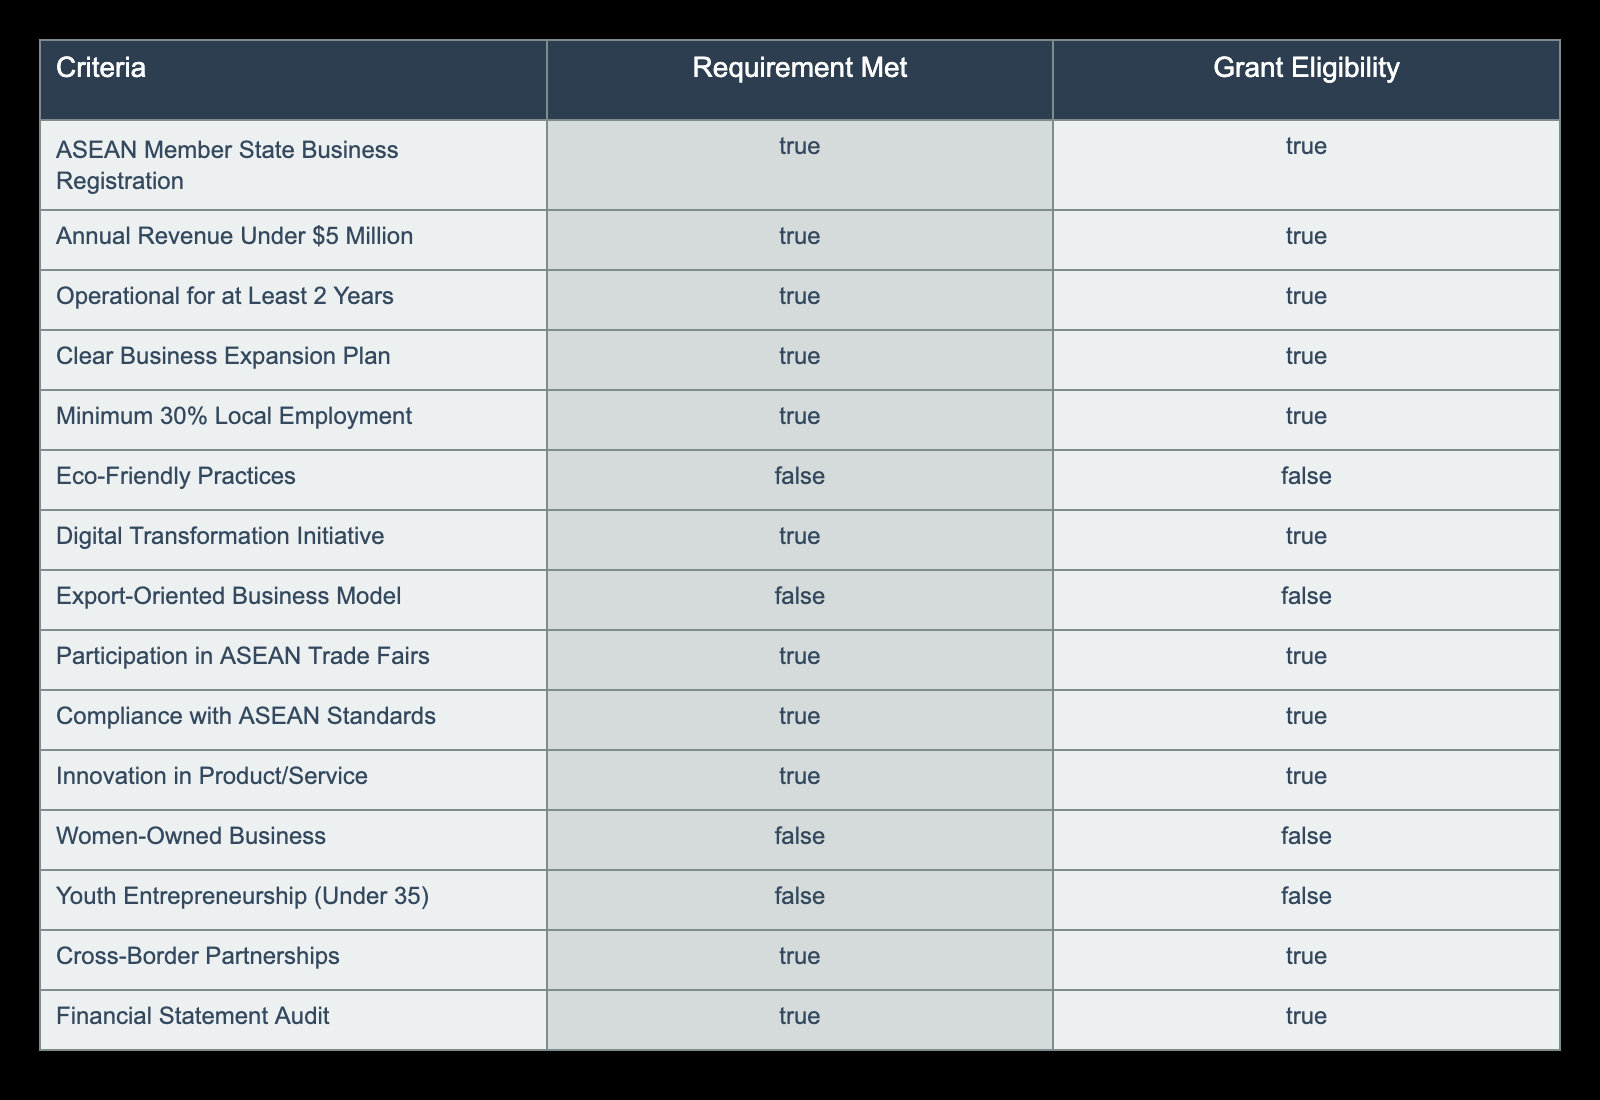What are the requirements that are met for grant eligibility? The table indicates that the following requirements are met for grant eligibility: ASEAN Member State Business Registration, Annual Revenue Under $5 Million, Operational for At Least 2 Years, Clear Business Expansion Plan, Minimum 30% Local Employment, Digital Transformation Initiative, Participation in ASEAN Trade Fairs, Compliance with ASEAN Standards, Innovation in Product/Service, Cross-Border Partnerships, and Financial Statement Audit.
Answer: ASEAN Member State Business Registration, Annual Revenue Under $5 Million, Operational for At Least 2 Years, Clear Business Expansion Plan, Minimum 30% Local Employment, Digital Transformation Initiative, Participation in ASEAN Trade Fairs, Compliance with ASEAN Standards, Innovation in Product/Service, Cross-Border Partnerships, Financial Statement Audit How many criteria are not met for grant eligibility? The table shows that there are four criteria not met for grant eligibility: Eco-Friendly Practices, Export-Oriented Business Model, Women-Owned Business, and Youth Entrepreneurship. Therefore, the total number of criteria not met is 4.
Answer: 4 Is having a clear business expansion plan a requirement for grant eligibility? According to the table, having a clear business expansion plan is marked as TRUE under the requirement met column, which means it is indeed a requirement for grant eligibility.
Answer: Yes What percentage of the criteria met are required for grant eligibility? There are 15 criteria total listed in the table. Out of these, 11 criteria are marked as requirements met for grant eligibility. The percentage is calculated as (11/15) * 100 = 73.33%.
Answer: 73.33% If a business is both women-owned and focused on digital transformation, will it be eligible for the grant? The table indicates that being a women-owned business is marked as FALSE under grant eligibility, despite meeting the digital transformation requirement (TRUE). Since a single criterion is FALSE (women-owned), the overall eligibility is not guaranteed regardless of meeting other criteria. Therefore, it will not be eligible.
Answer: No 